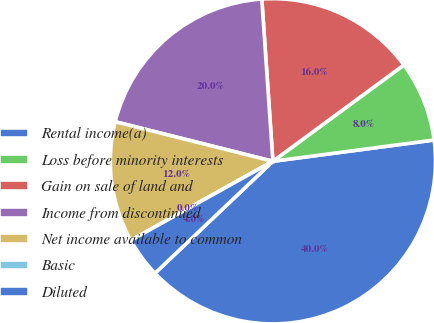<chart> <loc_0><loc_0><loc_500><loc_500><pie_chart><fcel>Rental income(a)<fcel>Loss before minority interests<fcel>Gain on sale of land and<fcel>Income from discontinued<fcel>Net income available to common<fcel>Basic<fcel>Diluted<nl><fcel>40.0%<fcel>8.0%<fcel>16.0%<fcel>20.0%<fcel>12.0%<fcel>0.0%<fcel>4.0%<nl></chart> 